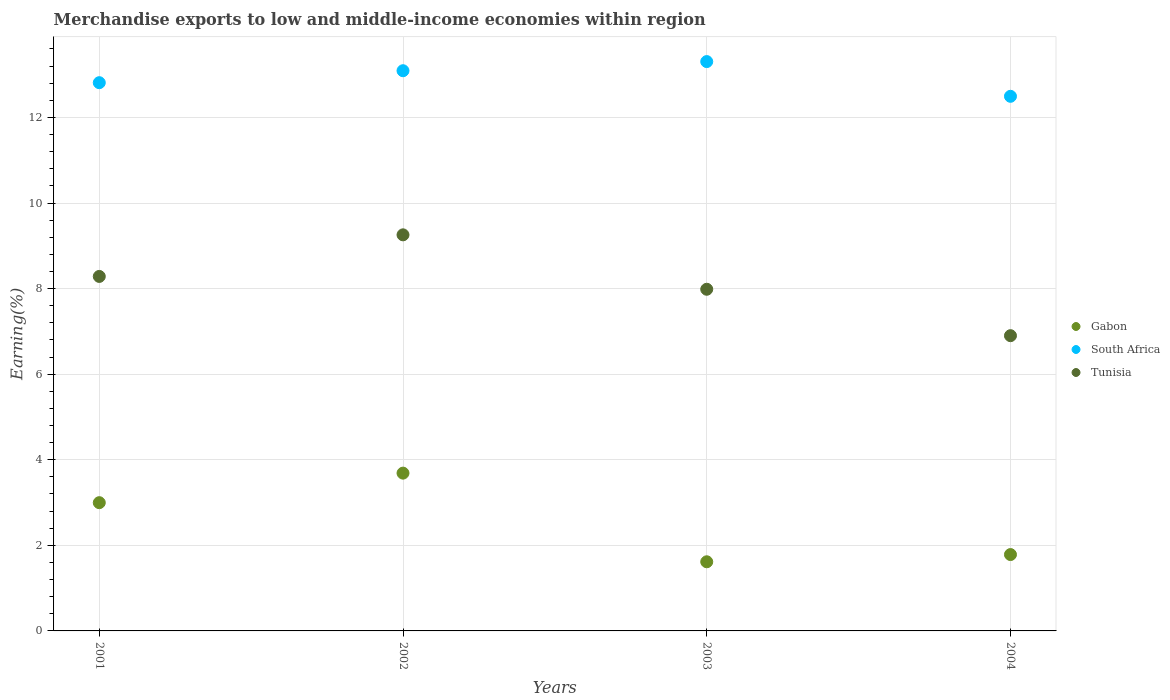What is the percentage of amount earned from merchandise exports in South Africa in 2004?
Provide a short and direct response. 12.49. Across all years, what is the maximum percentage of amount earned from merchandise exports in Gabon?
Offer a very short reply. 3.69. Across all years, what is the minimum percentage of amount earned from merchandise exports in Tunisia?
Your answer should be very brief. 6.9. In which year was the percentage of amount earned from merchandise exports in South Africa maximum?
Provide a short and direct response. 2003. What is the total percentage of amount earned from merchandise exports in Tunisia in the graph?
Your answer should be compact. 32.43. What is the difference between the percentage of amount earned from merchandise exports in South Africa in 2003 and that in 2004?
Provide a succinct answer. 0.81. What is the difference between the percentage of amount earned from merchandise exports in Gabon in 2002 and the percentage of amount earned from merchandise exports in Tunisia in 2003?
Your answer should be compact. -4.3. What is the average percentage of amount earned from merchandise exports in Tunisia per year?
Give a very brief answer. 8.11. In the year 2003, what is the difference between the percentage of amount earned from merchandise exports in Tunisia and percentage of amount earned from merchandise exports in Gabon?
Offer a very short reply. 6.37. What is the ratio of the percentage of amount earned from merchandise exports in Gabon in 2001 to that in 2004?
Give a very brief answer. 1.68. Is the percentage of amount earned from merchandise exports in South Africa in 2001 less than that in 2002?
Your response must be concise. Yes. Is the difference between the percentage of amount earned from merchandise exports in Tunisia in 2001 and 2002 greater than the difference between the percentage of amount earned from merchandise exports in Gabon in 2001 and 2002?
Provide a succinct answer. No. What is the difference between the highest and the second highest percentage of amount earned from merchandise exports in Gabon?
Offer a very short reply. 0.69. What is the difference between the highest and the lowest percentage of amount earned from merchandise exports in South Africa?
Offer a very short reply. 0.81. Is it the case that in every year, the sum of the percentage of amount earned from merchandise exports in South Africa and percentage of amount earned from merchandise exports in Gabon  is greater than the percentage of amount earned from merchandise exports in Tunisia?
Make the answer very short. Yes. Is the percentage of amount earned from merchandise exports in Gabon strictly greater than the percentage of amount earned from merchandise exports in Tunisia over the years?
Your response must be concise. No. Is the percentage of amount earned from merchandise exports in Gabon strictly less than the percentage of amount earned from merchandise exports in Tunisia over the years?
Keep it short and to the point. Yes. Does the graph contain grids?
Keep it short and to the point. Yes. How many legend labels are there?
Provide a succinct answer. 3. What is the title of the graph?
Your answer should be very brief. Merchandise exports to low and middle-income economies within region. Does "Mali" appear as one of the legend labels in the graph?
Provide a short and direct response. No. What is the label or title of the X-axis?
Provide a succinct answer. Years. What is the label or title of the Y-axis?
Provide a short and direct response. Earning(%). What is the Earning(%) in Gabon in 2001?
Your response must be concise. 3. What is the Earning(%) of South Africa in 2001?
Offer a very short reply. 12.81. What is the Earning(%) in Tunisia in 2001?
Make the answer very short. 8.28. What is the Earning(%) of Gabon in 2002?
Keep it short and to the point. 3.69. What is the Earning(%) in South Africa in 2002?
Offer a terse response. 13.09. What is the Earning(%) of Tunisia in 2002?
Your response must be concise. 9.26. What is the Earning(%) of Gabon in 2003?
Give a very brief answer. 1.62. What is the Earning(%) of South Africa in 2003?
Your response must be concise. 13.31. What is the Earning(%) of Tunisia in 2003?
Keep it short and to the point. 7.98. What is the Earning(%) in Gabon in 2004?
Give a very brief answer. 1.78. What is the Earning(%) of South Africa in 2004?
Give a very brief answer. 12.49. What is the Earning(%) of Tunisia in 2004?
Offer a terse response. 6.9. Across all years, what is the maximum Earning(%) in Gabon?
Your answer should be compact. 3.69. Across all years, what is the maximum Earning(%) in South Africa?
Ensure brevity in your answer.  13.31. Across all years, what is the maximum Earning(%) in Tunisia?
Give a very brief answer. 9.26. Across all years, what is the minimum Earning(%) of Gabon?
Provide a succinct answer. 1.62. Across all years, what is the minimum Earning(%) in South Africa?
Offer a terse response. 12.49. Across all years, what is the minimum Earning(%) of Tunisia?
Offer a terse response. 6.9. What is the total Earning(%) in Gabon in the graph?
Give a very brief answer. 10.09. What is the total Earning(%) of South Africa in the graph?
Provide a succinct answer. 51.7. What is the total Earning(%) in Tunisia in the graph?
Offer a terse response. 32.43. What is the difference between the Earning(%) of Gabon in 2001 and that in 2002?
Ensure brevity in your answer.  -0.69. What is the difference between the Earning(%) of South Africa in 2001 and that in 2002?
Offer a terse response. -0.28. What is the difference between the Earning(%) of Tunisia in 2001 and that in 2002?
Your answer should be compact. -0.97. What is the difference between the Earning(%) in Gabon in 2001 and that in 2003?
Your answer should be very brief. 1.38. What is the difference between the Earning(%) in South Africa in 2001 and that in 2003?
Your response must be concise. -0.49. What is the difference between the Earning(%) of Tunisia in 2001 and that in 2003?
Offer a very short reply. 0.3. What is the difference between the Earning(%) of Gabon in 2001 and that in 2004?
Your answer should be very brief. 1.21. What is the difference between the Earning(%) in South Africa in 2001 and that in 2004?
Ensure brevity in your answer.  0.32. What is the difference between the Earning(%) of Tunisia in 2001 and that in 2004?
Your answer should be compact. 1.38. What is the difference between the Earning(%) in Gabon in 2002 and that in 2003?
Your response must be concise. 2.07. What is the difference between the Earning(%) of South Africa in 2002 and that in 2003?
Give a very brief answer. -0.21. What is the difference between the Earning(%) of Tunisia in 2002 and that in 2003?
Make the answer very short. 1.27. What is the difference between the Earning(%) in Gabon in 2002 and that in 2004?
Your answer should be very brief. 1.9. What is the difference between the Earning(%) of South Africa in 2002 and that in 2004?
Provide a succinct answer. 0.6. What is the difference between the Earning(%) in Tunisia in 2002 and that in 2004?
Provide a short and direct response. 2.36. What is the difference between the Earning(%) of Gabon in 2003 and that in 2004?
Your answer should be compact. -0.17. What is the difference between the Earning(%) in South Africa in 2003 and that in 2004?
Offer a terse response. 0.81. What is the difference between the Earning(%) in Tunisia in 2003 and that in 2004?
Provide a succinct answer. 1.08. What is the difference between the Earning(%) of Gabon in 2001 and the Earning(%) of South Africa in 2002?
Your answer should be compact. -10.09. What is the difference between the Earning(%) of Gabon in 2001 and the Earning(%) of Tunisia in 2002?
Your answer should be compact. -6.26. What is the difference between the Earning(%) in South Africa in 2001 and the Earning(%) in Tunisia in 2002?
Offer a terse response. 3.56. What is the difference between the Earning(%) of Gabon in 2001 and the Earning(%) of South Africa in 2003?
Your answer should be very brief. -10.31. What is the difference between the Earning(%) in Gabon in 2001 and the Earning(%) in Tunisia in 2003?
Your answer should be compact. -4.99. What is the difference between the Earning(%) of South Africa in 2001 and the Earning(%) of Tunisia in 2003?
Your answer should be compact. 4.83. What is the difference between the Earning(%) in Gabon in 2001 and the Earning(%) in South Africa in 2004?
Provide a short and direct response. -9.5. What is the difference between the Earning(%) in Gabon in 2001 and the Earning(%) in Tunisia in 2004?
Keep it short and to the point. -3.9. What is the difference between the Earning(%) in South Africa in 2001 and the Earning(%) in Tunisia in 2004?
Your response must be concise. 5.91. What is the difference between the Earning(%) of Gabon in 2002 and the Earning(%) of South Africa in 2003?
Provide a succinct answer. -9.62. What is the difference between the Earning(%) of Gabon in 2002 and the Earning(%) of Tunisia in 2003?
Provide a succinct answer. -4.3. What is the difference between the Earning(%) in South Africa in 2002 and the Earning(%) in Tunisia in 2003?
Provide a succinct answer. 5.11. What is the difference between the Earning(%) in Gabon in 2002 and the Earning(%) in South Africa in 2004?
Keep it short and to the point. -8.81. What is the difference between the Earning(%) in Gabon in 2002 and the Earning(%) in Tunisia in 2004?
Make the answer very short. -3.21. What is the difference between the Earning(%) in South Africa in 2002 and the Earning(%) in Tunisia in 2004?
Ensure brevity in your answer.  6.19. What is the difference between the Earning(%) in Gabon in 2003 and the Earning(%) in South Africa in 2004?
Your response must be concise. -10.88. What is the difference between the Earning(%) of Gabon in 2003 and the Earning(%) of Tunisia in 2004?
Provide a succinct answer. -5.28. What is the difference between the Earning(%) in South Africa in 2003 and the Earning(%) in Tunisia in 2004?
Your answer should be very brief. 6.41. What is the average Earning(%) in Gabon per year?
Offer a terse response. 2.52. What is the average Earning(%) of South Africa per year?
Your answer should be compact. 12.93. What is the average Earning(%) of Tunisia per year?
Keep it short and to the point. 8.11. In the year 2001, what is the difference between the Earning(%) of Gabon and Earning(%) of South Africa?
Make the answer very short. -9.82. In the year 2001, what is the difference between the Earning(%) of Gabon and Earning(%) of Tunisia?
Offer a terse response. -5.29. In the year 2001, what is the difference between the Earning(%) of South Africa and Earning(%) of Tunisia?
Keep it short and to the point. 4.53. In the year 2002, what is the difference between the Earning(%) of Gabon and Earning(%) of South Africa?
Keep it short and to the point. -9.4. In the year 2002, what is the difference between the Earning(%) in Gabon and Earning(%) in Tunisia?
Your answer should be very brief. -5.57. In the year 2002, what is the difference between the Earning(%) of South Africa and Earning(%) of Tunisia?
Offer a terse response. 3.84. In the year 2003, what is the difference between the Earning(%) in Gabon and Earning(%) in South Africa?
Offer a very short reply. -11.69. In the year 2003, what is the difference between the Earning(%) in Gabon and Earning(%) in Tunisia?
Offer a very short reply. -6.37. In the year 2003, what is the difference between the Earning(%) of South Africa and Earning(%) of Tunisia?
Your answer should be very brief. 5.32. In the year 2004, what is the difference between the Earning(%) in Gabon and Earning(%) in South Africa?
Your answer should be very brief. -10.71. In the year 2004, what is the difference between the Earning(%) in Gabon and Earning(%) in Tunisia?
Offer a very short reply. -5.12. In the year 2004, what is the difference between the Earning(%) of South Africa and Earning(%) of Tunisia?
Your response must be concise. 5.59. What is the ratio of the Earning(%) of Gabon in 2001 to that in 2002?
Provide a succinct answer. 0.81. What is the ratio of the Earning(%) of South Africa in 2001 to that in 2002?
Give a very brief answer. 0.98. What is the ratio of the Earning(%) of Tunisia in 2001 to that in 2002?
Ensure brevity in your answer.  0.9. What is the ratio of the Earning(%) in Gabon in 2001 to that in 2003?
Keep it short and to the point. 1.85. What is the ratio of the Earning(%) in South Africa in 2001 to that in 2003?
Offer a very short reply. 0.96. What is the ratio of the Earning(%) in Tunisia in 2001 to that in 2003?
Your answer should be compact. 1.04. What is the ratio of the Earning(%) in Gabon in 2001 to that in 2004?
Provide a short and direct response. 1.68. What is the ratio of the Earning(%) in South Africa in 2001 to that in 2004?
Your answer should be compact. 1.03. What is the ratio of the Earning(%) in Tunisia in 2001 to that in 2004?
Ensure brevity in your answer.  1.2. What is the ratio of the Earning(%) of Gabon in 2002 to that in 2003?
Ensure brevity in your answer.  2.28. What is the ratio of the Earning(%) in South Africa in 2002 to that in 2003?
Offer a terse response. 0.98. What is the ratio of the Earning(%) in Tunisia in 2002 to that in 2003?
Offer a very short reply. 1.16. What is the ratio of the Earning(%) of Gabon in 2002 to that in 2004?
Your response must be concise. 2.07. What is the ratio of the Earning(%) of South Africa in 2002 to that in 2004?
Keep it short and to the point. 1.05. What is the ratio of the Earning(%) in Tunisia in 2002 to that in 2004?
Keep it short and to the point. 1.34. What is the ratio of the Earning(%) of Gabon in 2003 to that in 2004?
Ensure brevity in your answer.  0.91. What is the ratio of the Earning(%) of South Africa in 2003 to that in 2004?
Offer a very short reply. 1.06. What is the ratio of the Earning(%) of Tunisia in 2003 to that in 2004?
Your answer should be very brief. 1.16. What is the difference between the highest and the second highest Earning(%) in Gabon?
Your response must be concise. 0.69. What is the difference between the highest and the second highest Earning(%) of South Africa?
Your answer should be very brief. 0.21. What is the difference between the highest and the lowest Earning(%) of Gabon?
Offer a terse response. 2.07. What is the difference between the highest and the lowest Earning(%) of South Africa?
Ensure brevity in your answer.  0.81. What is the difference between the highest and the lowest Earning(%) of Tunisia?
Provide a succinct answer. 2.36. 